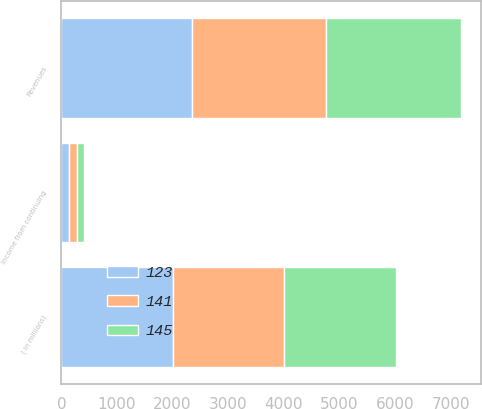Convert chart. <chart><loc_0><loc_0><loc_500><loc_500><stacked_bar_chart><ecel><fcel>( in millions)<fcel>Revenues<fcel>Income from continuing<nl><fcel>145<fcel>2004<fcel>2423<fcel>123<nl><fcel>123<fcel>2003<fcel>2357<fcel>141<nl><fcel>141<fcel>2002<fcel>2400<fcel>145<nl></chart> 